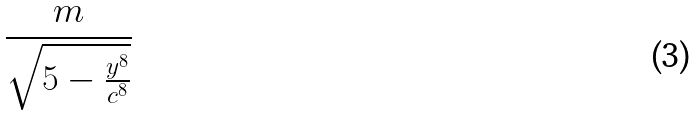<formula> <loc_0><loc_0><loc_500><loc_500>\frac { m } { \sqrt { 5 - \frac { y ^ { 8 } } { c ^ { 8 } } } }</formula> 